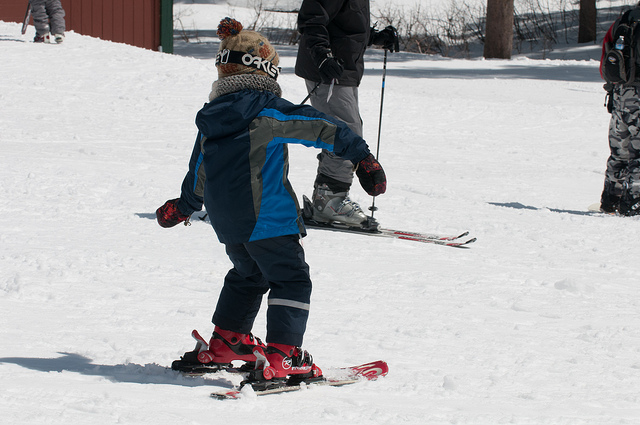Identify the text displayed in this image. OAKES 